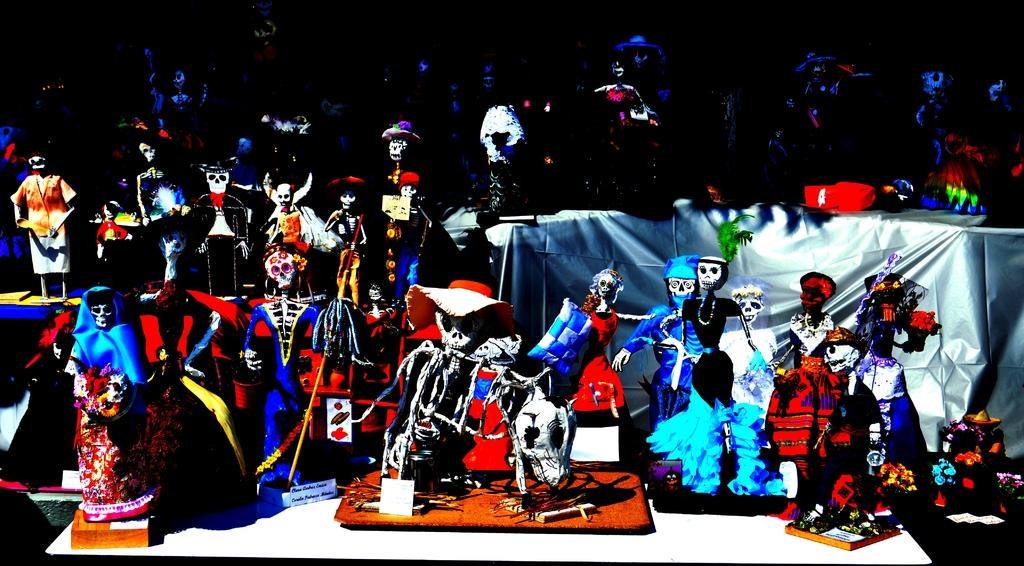In one or two sentences, can you explain what this image depicts? In this picture we can see the tables. On the tables we can see the clothes, dolls and toys. In the background the image is dark. 